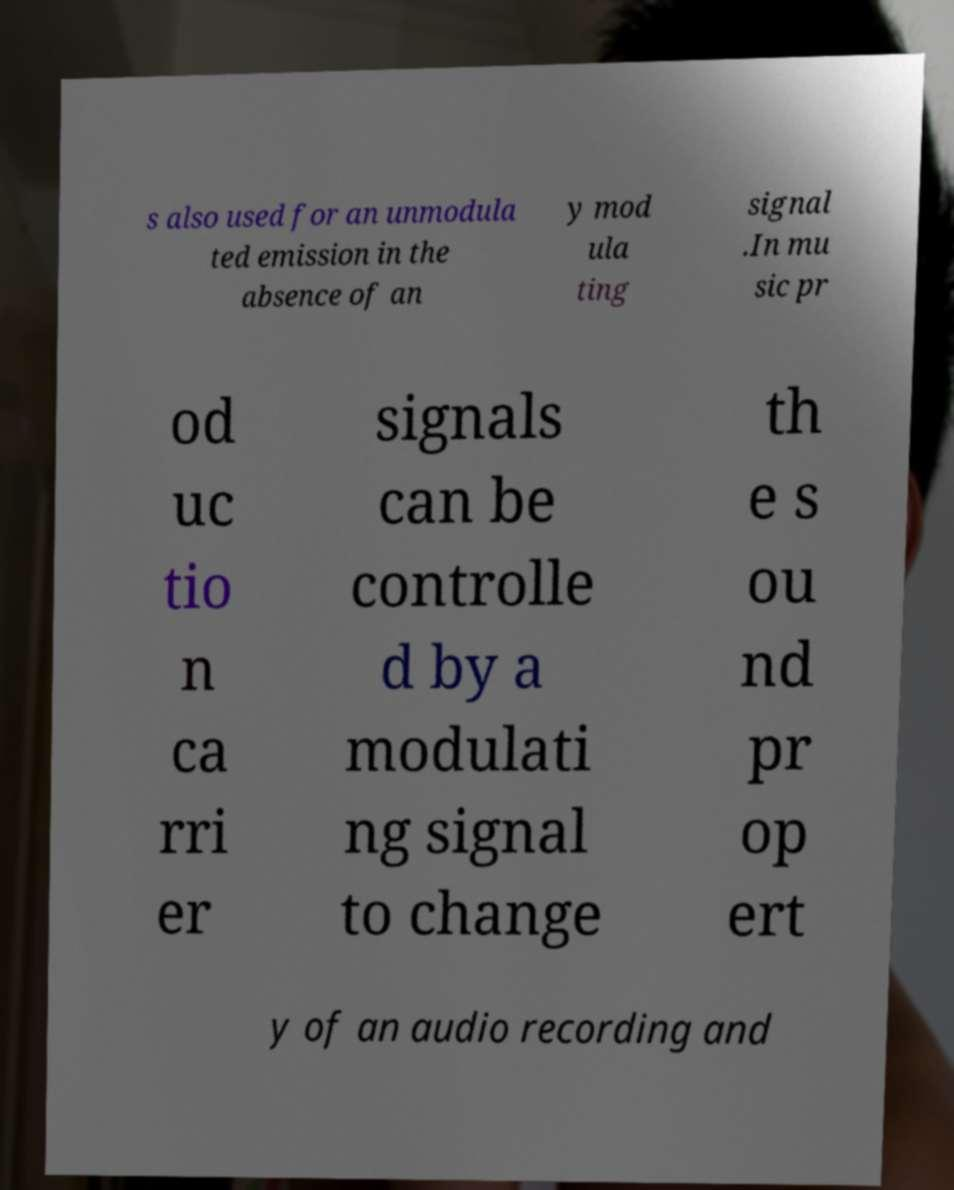Could you extract and type out the text from this image? s also used for an unmodula ted emission in the absence of an y mod ula ting signal .In mu sic pr od uc tio n ca rri er signals can be controlle d by a modulati ng signal to change th e s ou nd pr op ert y of an audio recording and 